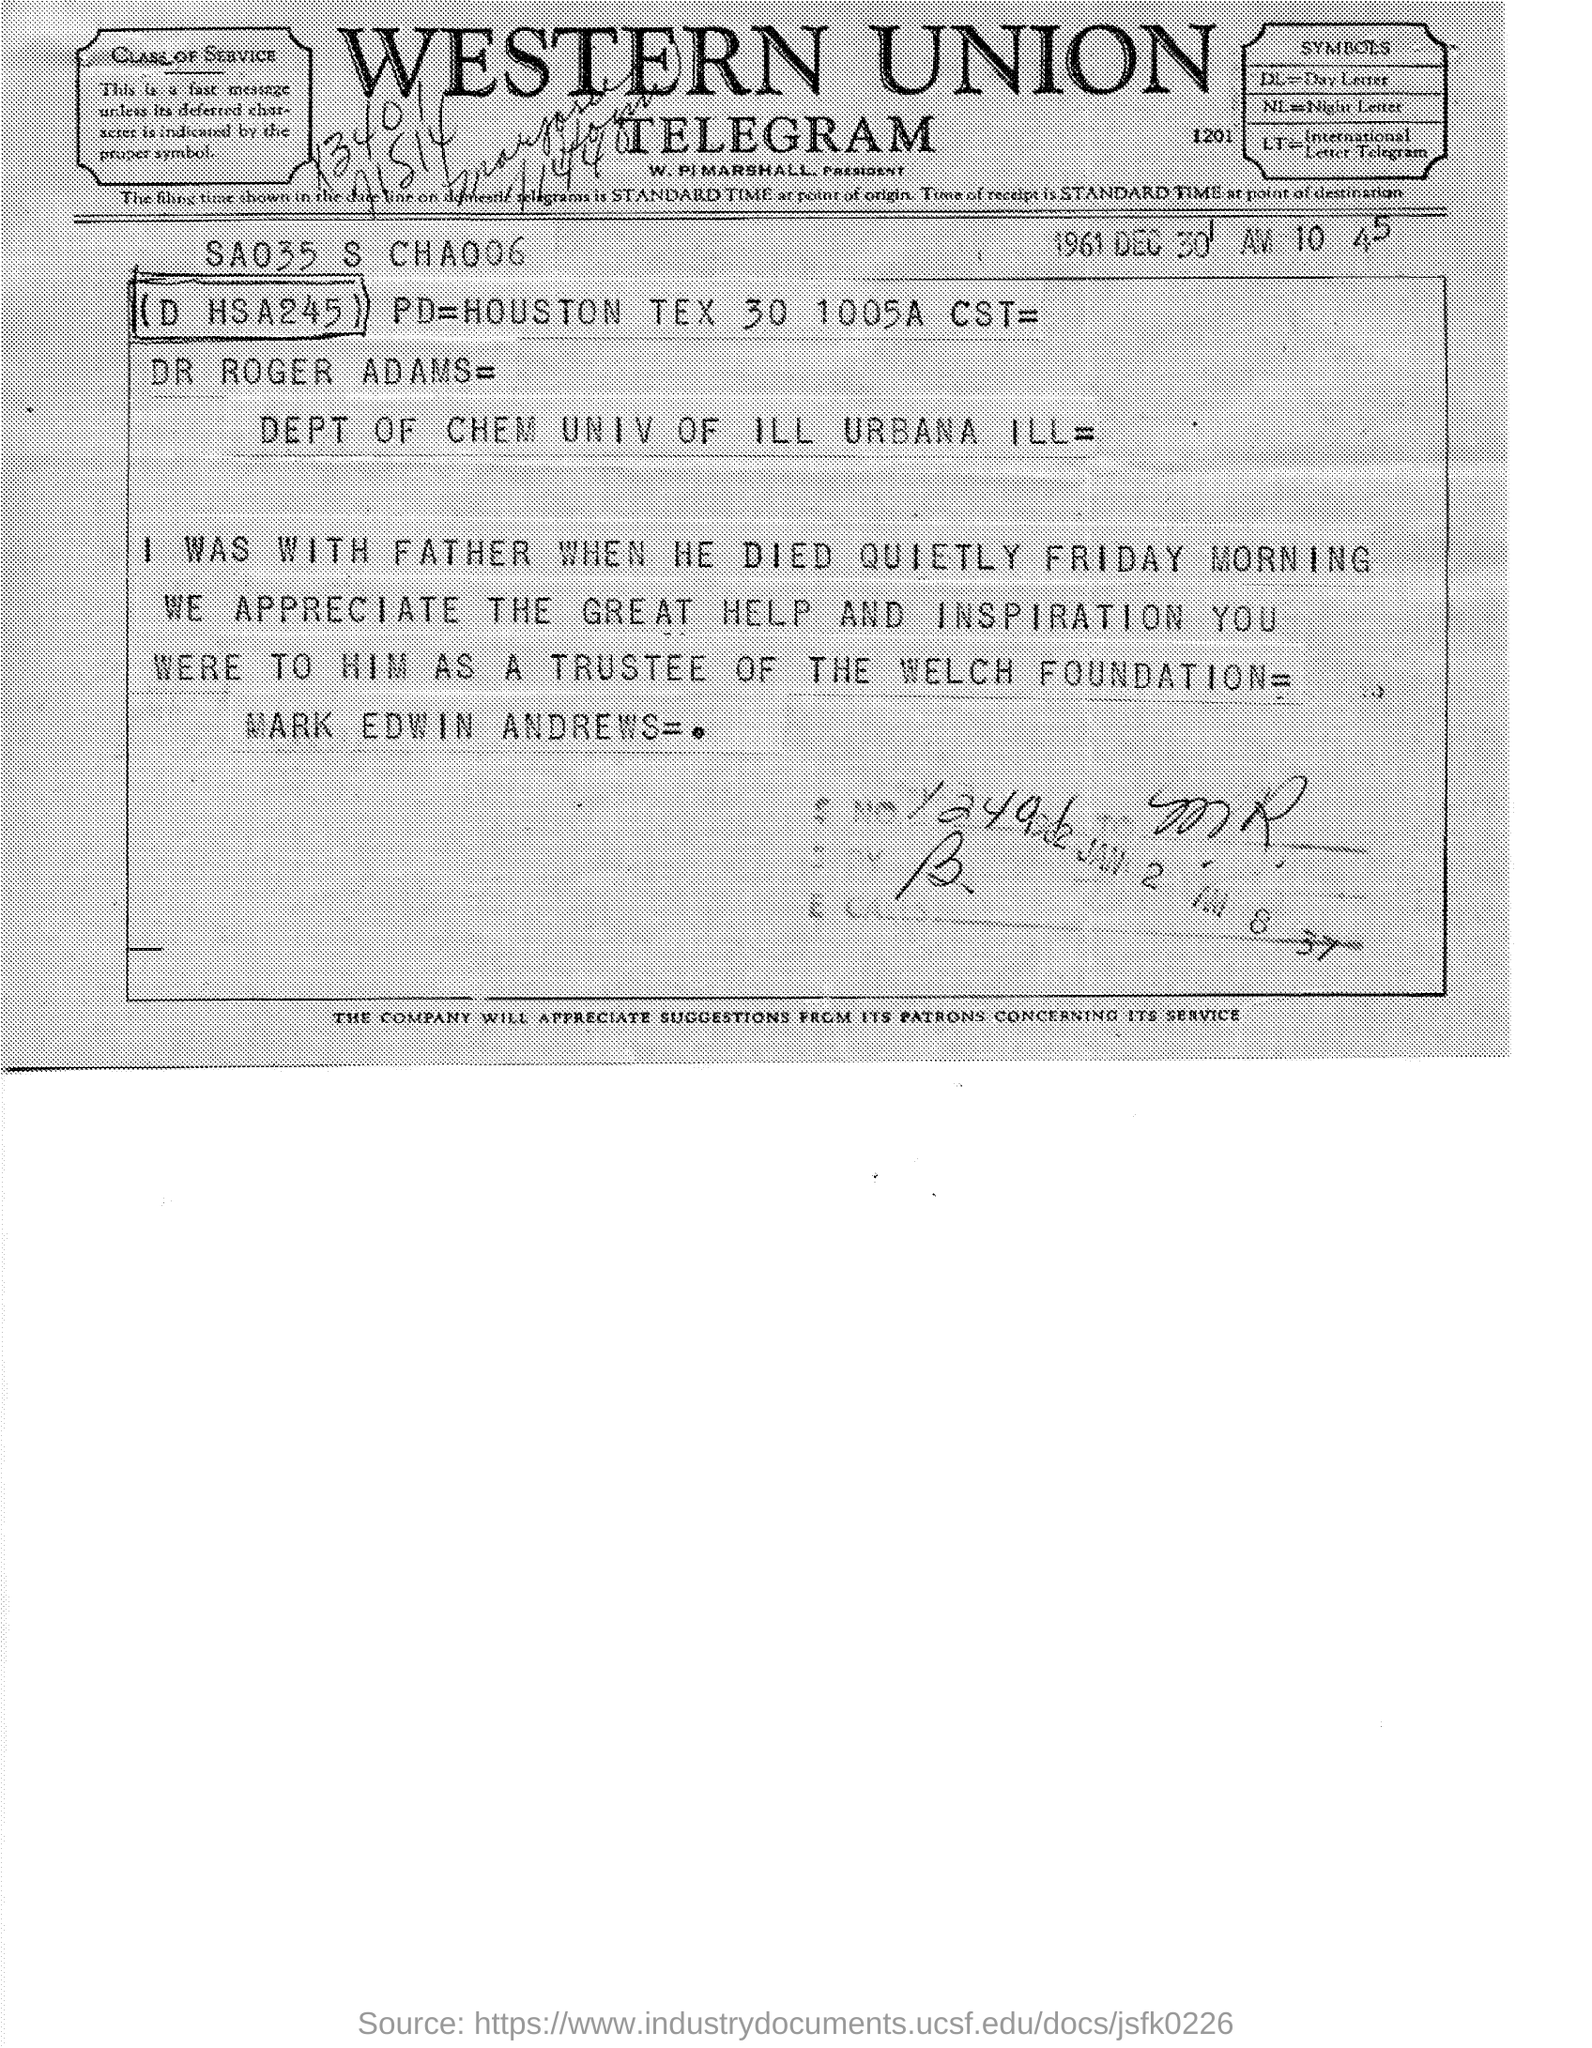Identify some key points in this picture. The firm mentioned at the top of the page is Western Union. This document is a telegram. The document is dated December 30, 1961. 